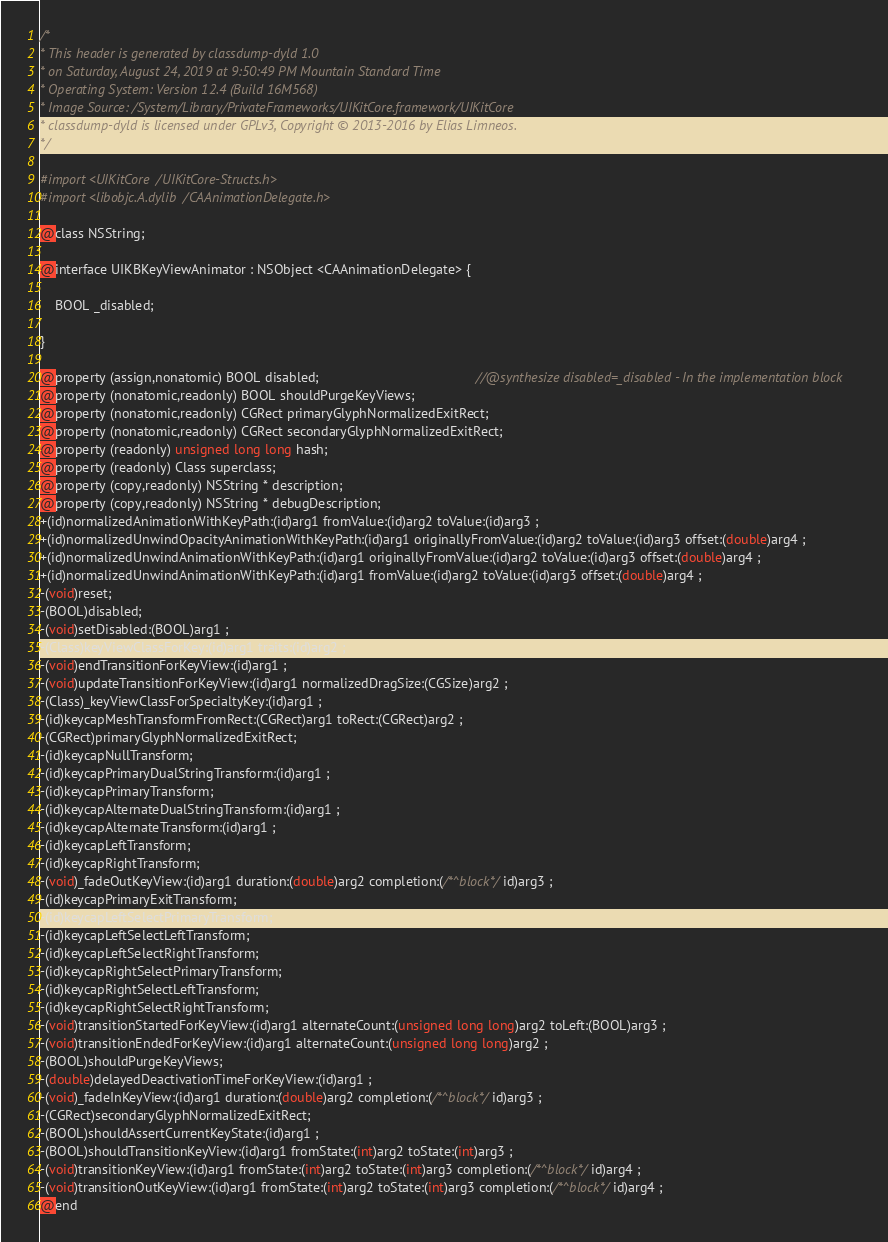Convert code to text. <code><loc_0><loc_0><loc_500><loc_500><_C_>/*
* This header is generated by classdump-dyld 1.0
* on Saturday, August 24, 2019 at 9:50:49 PM Mountain Standard Time
* Operating System: Version 12.4 (Build 16M568)
* Image Source: /System/Library/PrivateFrameworks/UIKitCore.framework/UIKitCore
* classdump-dyld is licensed under GPLv3, Copyright © 2013-2016 by Elias Limneos.
*/

#import <UIKitCore/UIKitCore-Structs.h>
#import <libobjc.A.dylib/CAAnimationDelegate.h>

@class NSString;

@interface UIKBKeyViewAnimator : NSObject <CAAnimationDelegate> {

	BOOL _disabled;

}

@property (assign,nonatomic) BOOL disabled;                                          //@synthesize disabled=_disabled - In the implementation block
@property (nonatomic,readonly) BOOL shouldPurgeKeyViews; 
@property (nonatomic,readonly) CGRect primaryGlyphNormalizedExitRect; 
@property (nonatomic,readonly) CGRect secondaryGlyphNormalizedExitRect; 
@property (readonly) unsigned long long hash; 
@property (readonly) Class superclass; 
@property (copy,readonly) NSString * description; 
@property (copy,readonly) NSString * debugDescription; 
+(id)normalizedAnimationWithKeyPath:(id)arg1 fromValue:(id)arg2 toValue:(id)arg3 ;
+(id)normalizedUnwindOpacityAnimationWithKeyPath:(id)arg1 originallyFromValue:(id)arg2 toValue:(id)arg3 offset:(double)arg4 ;
+(id)normalizedUnwindAnimationWithKeyPath:(id)arg1 originallyFromValue:(id)arg2 toValue:(id)arg3 offset:(double)arg4 ;
+(id)normalizedUnwindAnimationWithKeyPath:(id)arg1 fromValue:(id)arg2 toValue:(id)arg3 offset:(double)arg4 ;
-(void)reset;
-(BOOL)disabled;
-(void)setDisabled:(BOOL)arg1 ;
-(Class)keyViewClassForKey:(id)arg1 traits:(id)arg2 ;
-(void)endTransitionForKeyView:(id)arg1 ;
-(void)updateTransitionForKeyView:(id)arg1 normalizedDragSize:(CGSize)arg2 ;
-(Class)_keyViewClassForSpecialtyKey:(id)arg1 ;
-(id)keycapMeshTransformFromRect:(CGRect)arg1 toRect:(CGRect)arg2 ;
-(CGRect)primaryGlyphNormalizedExitRect;
-(id)keycapNullTransform;
-(id)keycapPrimaryDualStringTransform:(id)arg1 ;
-(id)keycapPrimaryTransform;
-(id)keycapAlternateDualStringTransform:(id)arg1 ;
-(id)keycapAlternateTransform:(id)arg1 ;
-(id)keycapLeftTransform;
-(id)keycapRightTransform;
-(void)_fadeOutKeyView:(id)arg1 duration:(double)arg2 completion:(/*^block*/id)arg3 ;
-(id)keycapPrimaryExitTransform;
-(id)keycapLeftSelectPrimaryTransform;
-(id)keycapLeftSelectLeftTransform;
-(id)keycapLeftSelectRightTransform;
-(id)keycapRightSelectPrimaryTransform;
-(id)keycapRightSelectLeftTransform;
-(id)keycapRightSelectRightTransform;
-(void)transitionStartedForKeyView:(id)arg1 alternateCount:(unsigned long long)arg2 toLeft:(BOOL)arg3 ;
-(void)transitionEndedForKeyView:(id)arg1 alternateCount:(unsigned long long)arg2 ;
-(BOOL)shouldPurgeKeyViews;
-(double)delayedDeactivationTimeForKeyView:(id)arg1 ;
-(void)_fadeInKeyView:(id)arg1 duration:(double)arg2 completion:(/*^block*/id)arg3 ;
-(CGRect)secondaryGlyphNormalizedExitRect;
-(BOOL)shouldAssertCurrentKeyState:(id)arg1 ;
-(BOOL)shouldTransitionKeyView:(id)arg1 fromState:(int)arg2 toState:(int)arg3 ;
-(void)transitionKeyView:(id)arg1 fromState:(int)arg2 toState:(int)arg3 completion:(/*^block*/id)arg4 ;
-(void)transitionOutKeyView:(id)arg1 fromState:(int)arg2 toState:(int)arg3 completion:(/*^block*/id)arg4 ;
@end

</code> 